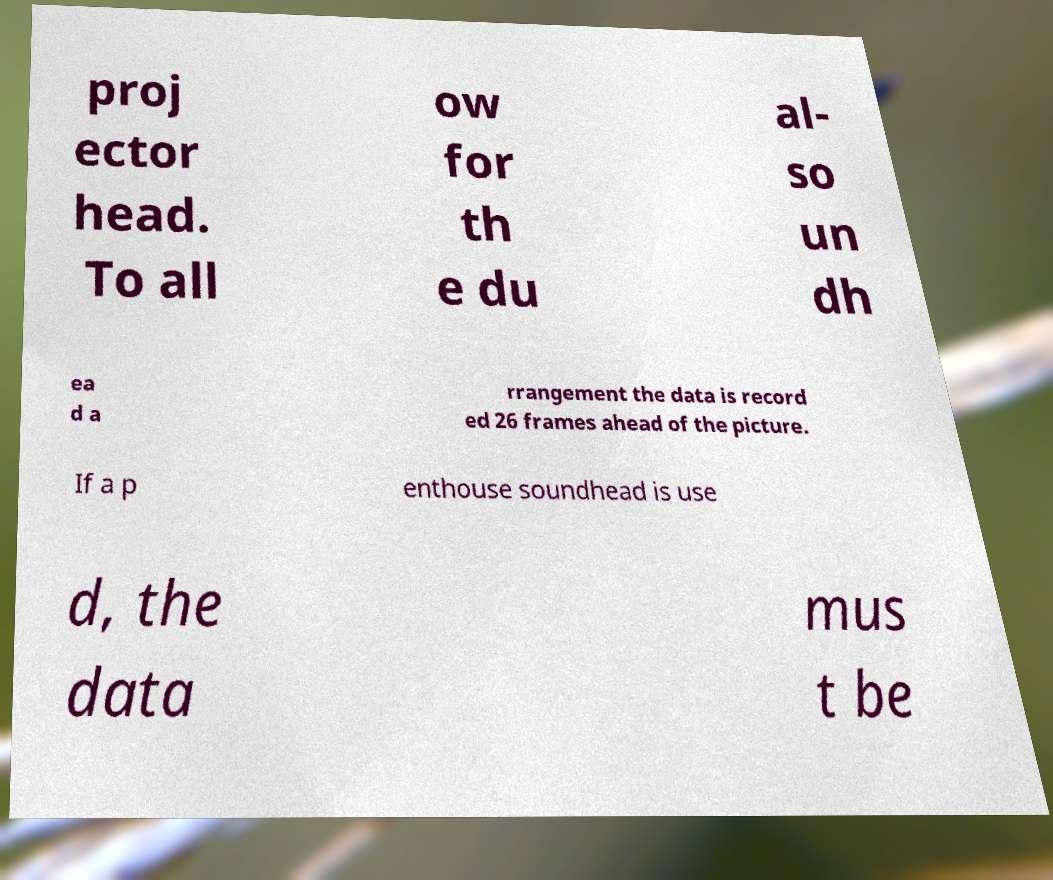For documentation purposes, I need the text within this image transcribed. Could you provide that? proj ector head. To all ow for th e du al- so un dh ea d a rrangement the data is record ed 26 frames ahead of the picture. If a p enthouse soundhead is use d, the data mus t be 